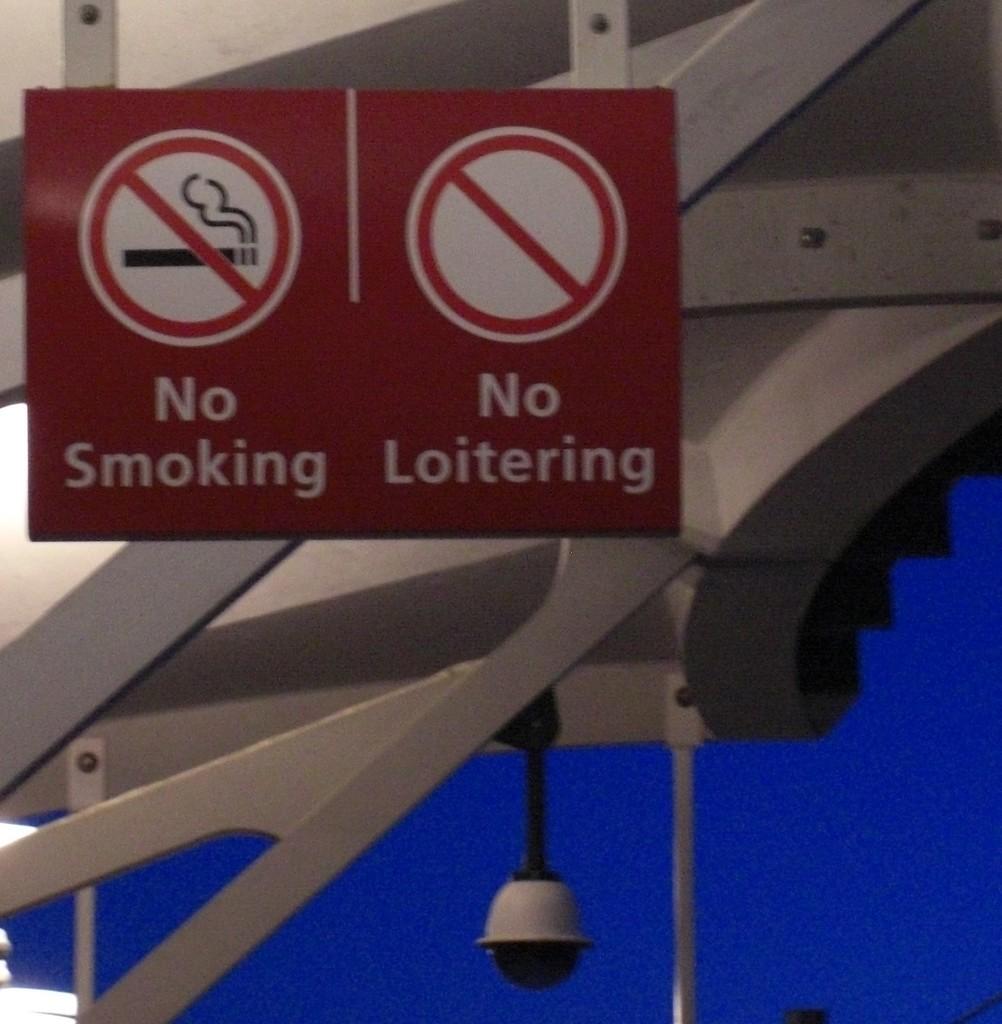What does the sign on the left say not to do?
Give a very brief answer. No smoking. 